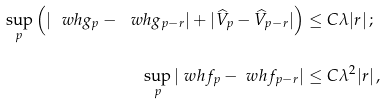<formula> <loc_0><loc_0><loc_500><loc_500>\sup _ { p } \left ( | \ w h g _ { p } - \ w h g _ { p - r } | + | { \widehat { V } } _ { p } - { \widehat { V } } _ { p - r } | \right ) & \leq C \lambda | r | \, ; \\ \sup _ { p } | \ w h f _ { p } - \ w h f _ { p - r } | & \leq C \lambda ^ { 2 } | r | \, ,</formula> 